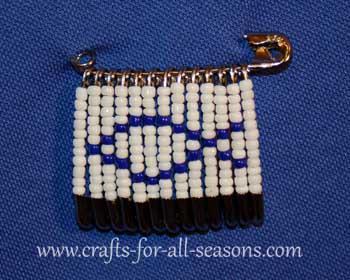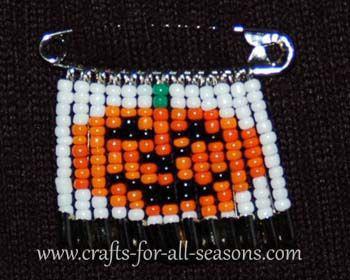The first image is the image on the left, the second image is the image on the right. For the images shown, is this caption "One safety pin jewelry item features a heart design using red, white, and blue beads." true? Answer yes or no. No. The first image is the image on the left, the second image is the image on the right. Analyze the images presented: Is the assertion "There is a heart pattern made of beads in at least one of the images." valid? Answer yes or no. No. 